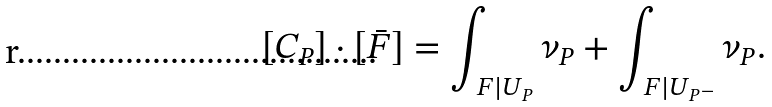<formula> <loc_0><loc_0><loc_500><loc_500>[ C _ { P } ] \cdot [ \bar { F } ] = \int _ { \ F | U _ { P } } \nu _ { P } + \int _ { \ F | U _ { P ^ { - } } } \nu _ { P } .</formula> 